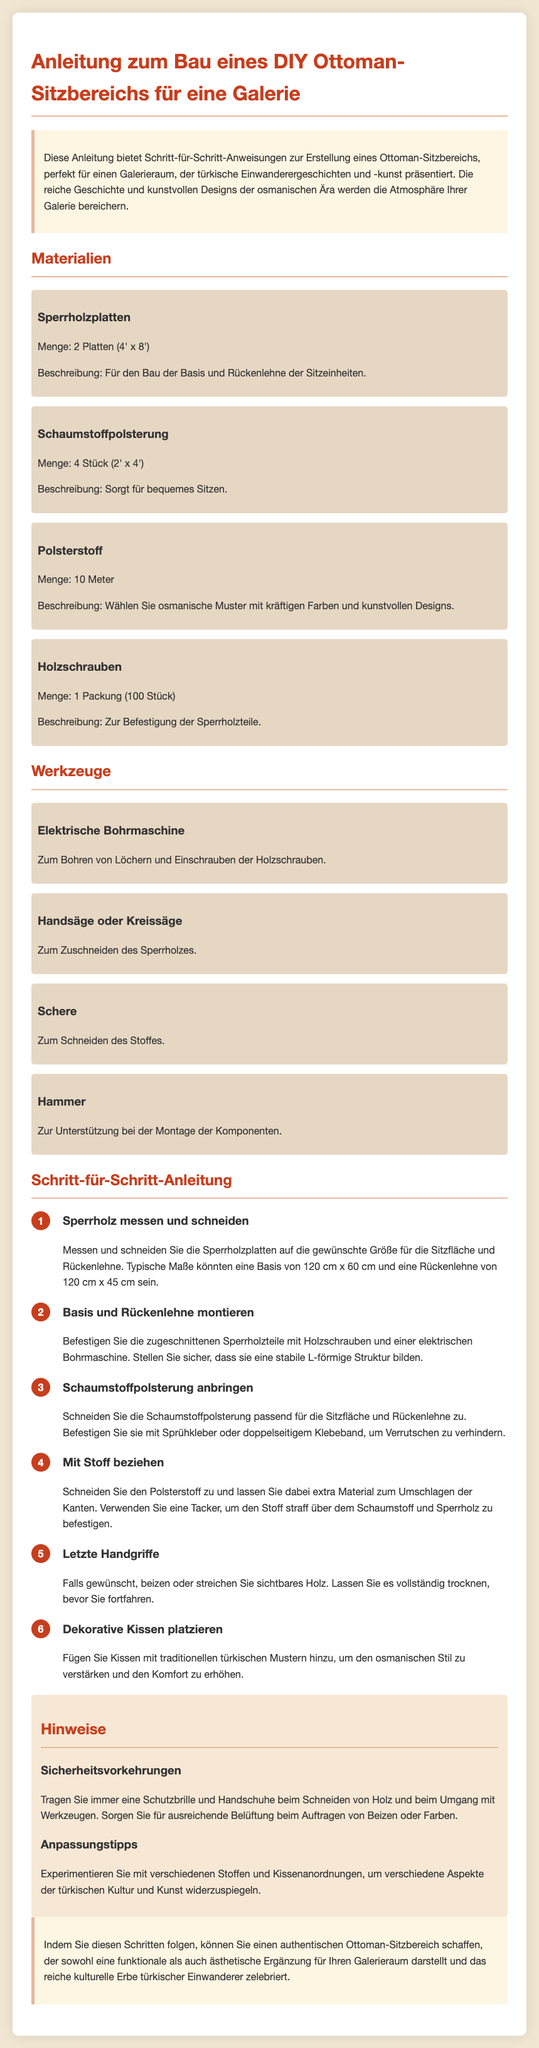Was ist der Titel der Anleitung? Der Titel ist die Hauptüberschrift, die den Inhalt der Anleitung beschreibt.
Answer: Anleitung zum Bau eines DIY Ottoman-Sitzbereichs für eine Galerie Wie viele Sperrholzplatten werden benötigt? Die benötigte Anzahl der Sperrholzplatten ist in der Liste der Materialien angegeben.
Answer: 2 Platten Was ist die Menge des Polsterstoffs? Die Menge des Polsterstoffs steht unter Materialien.
Answer: 10 Meter Wie hoch ist die Rückenlehne typischerweise? Die typischen Maße für die Rückenlehne sind in der Schritt-für-Schritt-Anleitung aufgeführt.
Answer: 45 cm Welches Werkzeug wird zum Bohren verwendet? Das Werkzeug, das zum Bohren von Löchern verwendet wird, wird in der Liste der Werkzeuge angegeben.
Answer: Elektrische Bohrmaschine Welche Vorsichtsmaßnahme wird beim Schneiden von Holz empfohlen? Die Sicherheitsvorkehrungen sind in den Hinweisen enthalten und betreffen den Umgang mit Werkzeugen.
Answer: Schutzbrille Wie sollten die Kissen gestaltet sein? Die Hinweise zu den Kissen geben an, welche Art von Mustern verwendet werden sollten.
Answer: Traditionelle türkische Muster Was ist der letzte Schritt in der Anleitung? Der letzte Schritt umfasst finale Anpassungen und wird in der Schritt-für-Schritt-Anleitung beschrieben.
Answer: Dekorative Kissen platzieren Wie viele Stücke Schaumstoffpolsterung werden benötigt? Die benötigte Anzahl der Schaumstoffpolsterung wird in der Liste der Materialien genannt.
Answer: 4 Stück 